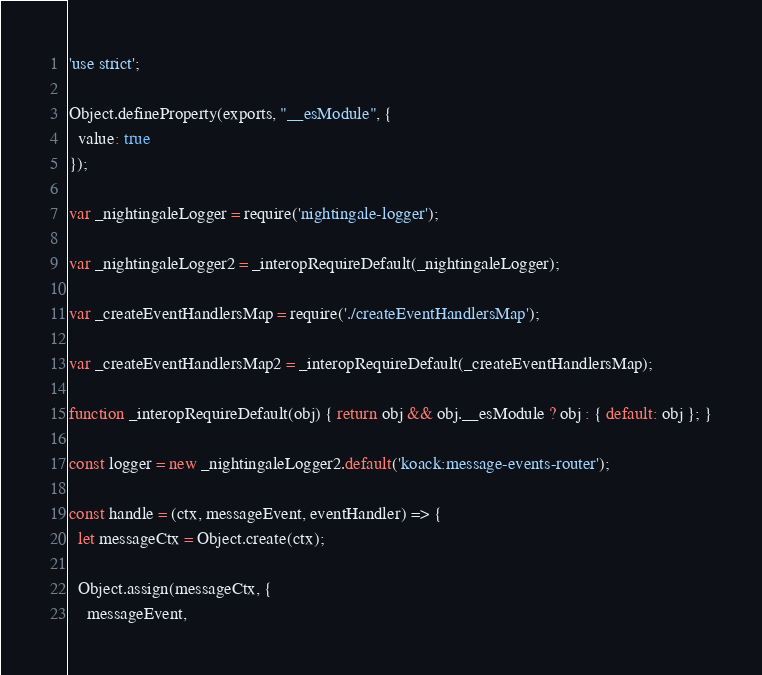Convert code to text. <code><loc_0><loc_0><loc_500><loc_500><_JavaScript_>'use strict';

Object.defineProperty(exports, "__esModule", {
  value: true
});

var _nightingaleLogger = require('nightingale-logger');

var _nightingaleLogger2 = _interopRequireDefault(_nightingaleLogger);

var _createEventHandlersMap = require('./createEventHandlersMap');

var _createEventHandlersMap2 = _interopRequireDefault(_createEventHandlersMap);

function _interopRequireDefault(obj) { return obj && obj.__esModule ? obj : { default: obj }; }

const logger = new _nightingaleLogger2.default('koack:message-events-router');

const handle = (ctx, messageEvent, eventHandler) => {
  let messageCtx = Object.create(ctx);

  Object.assign(messageCtx, {
    messageEvent,</code> 